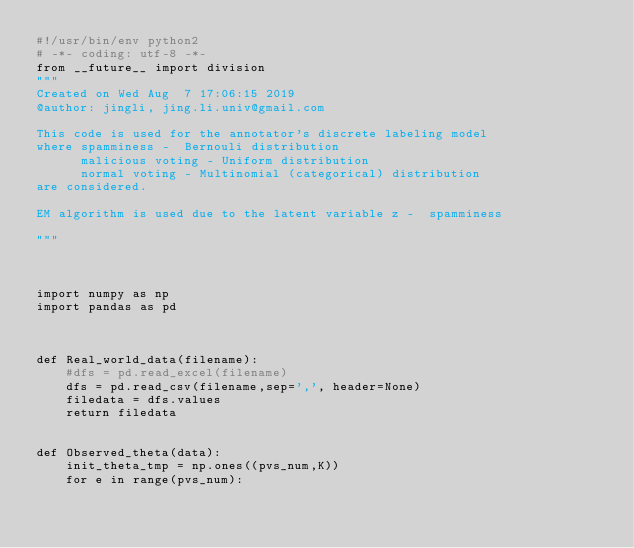Convert code to text. <code><loc_0><loc_0><loc_500><loc_500><_Python_>#!/usr/bin/env python2
# -*- coding: utf-8 -*-
from __future__ import division
"""
Created on Wed Aug  7 17:06:15 2019
@author: jingli, jing.li.univ@gmail.com

This code is used for the annotator's discrete labeling model
where spamminess -  Bernouli distribution
      malicious voting - Uniform distribution
      normal voting - Multinomial (categorical) distribution
are considered.

EM algorithm is used due to the latent variable z -  spamminess

"""



import numpy as np
import pandas as pd



def Real_world_data(filename):
    #dfs = pd.read_excel(filename)
    dfs = pd.read_csv(filename,sep=',', header=None)
    filedata = dfs.values
    return filedata
    

def Observed_theta(data):
    init_theta_tmp = np.ones((pvs_num,K))
    for e in range(pvs_num):</code> 